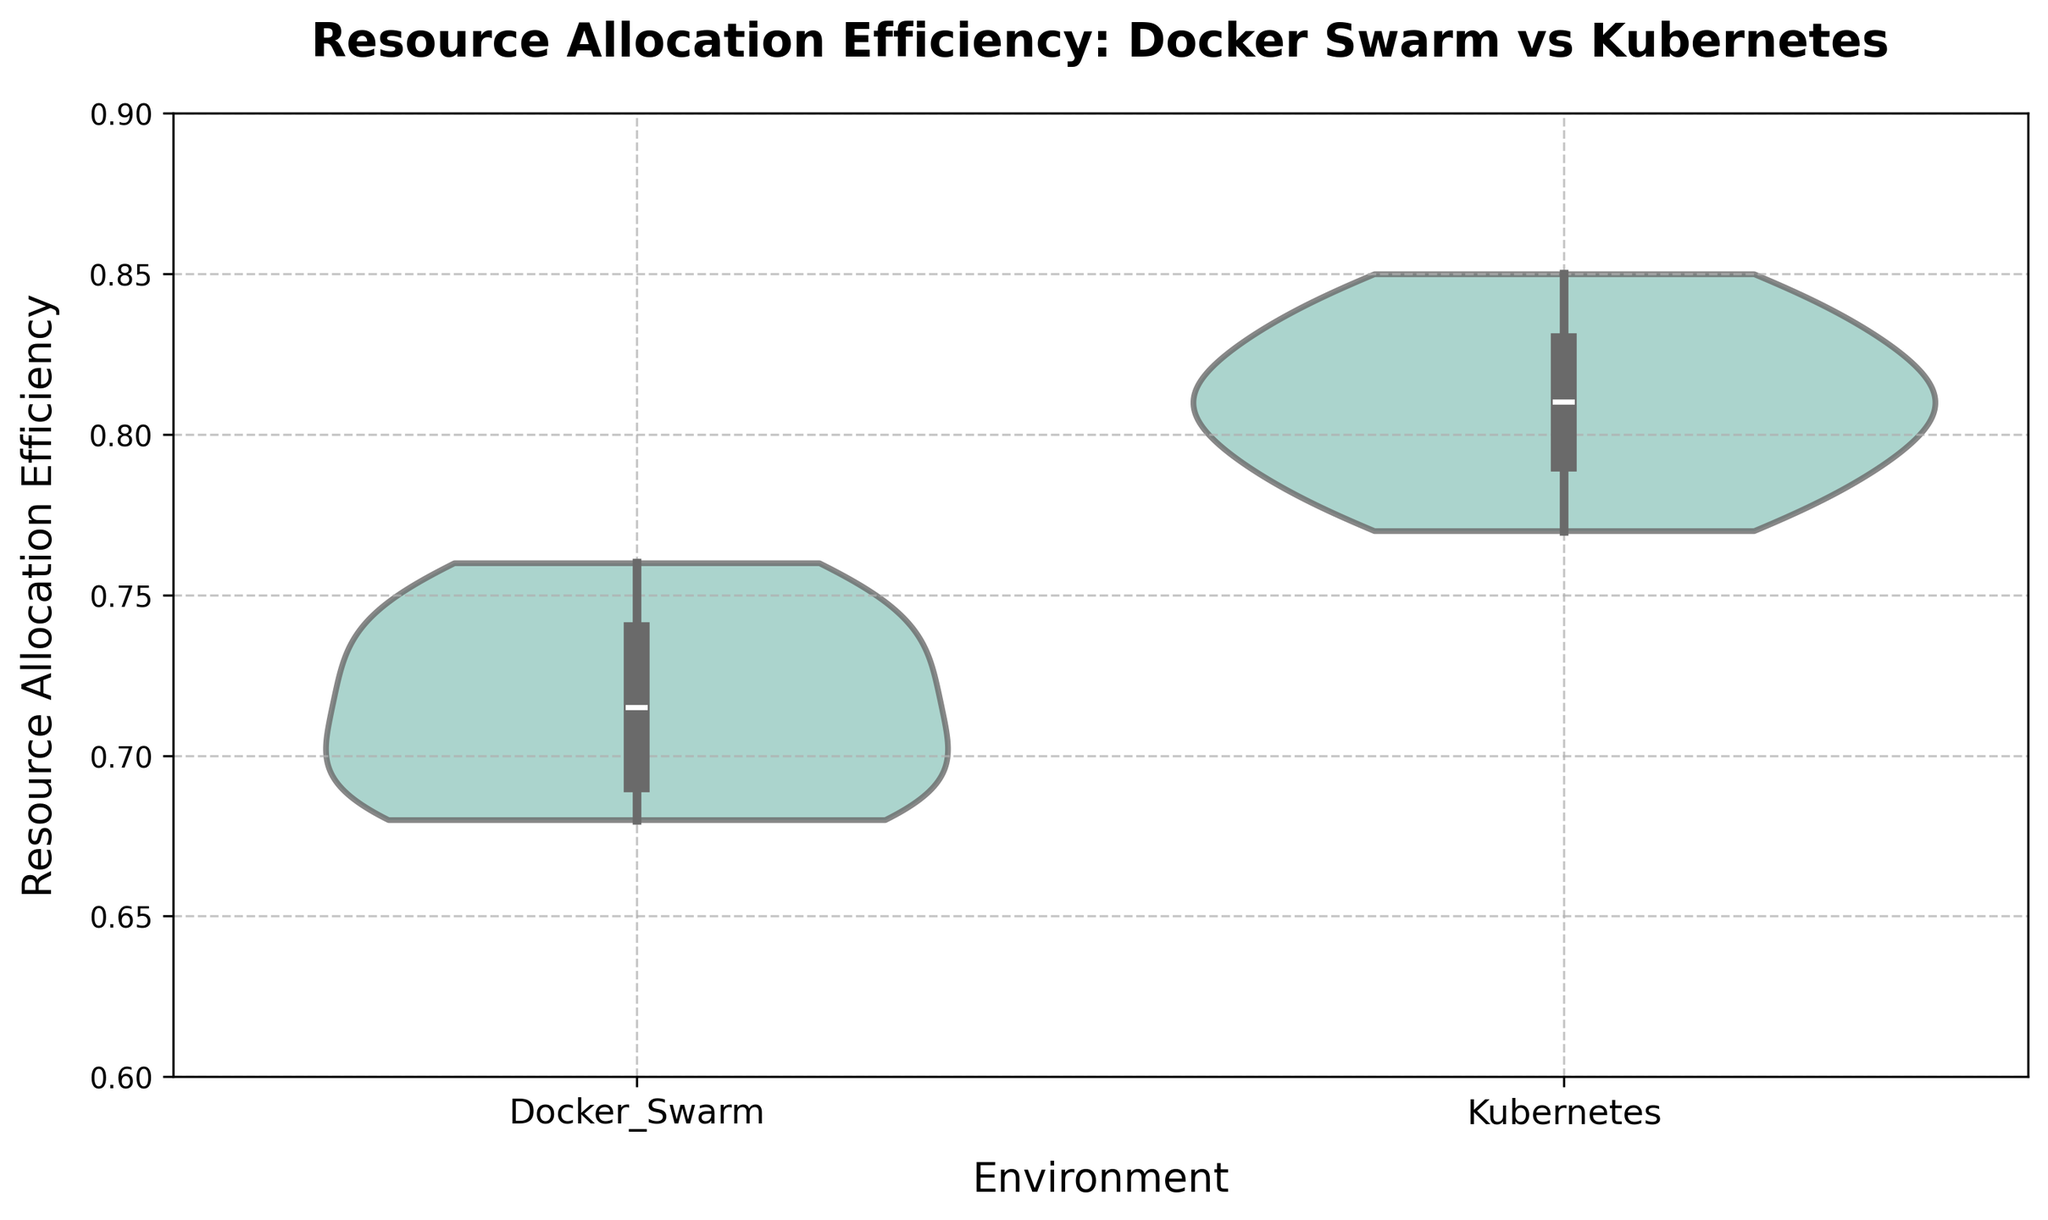what's the title of the figure? The title is generally placed at the top and it's meant to give an overview of what the figure represents. The title in this case would be directly visible.
Answer: Resource Allocation Efficiency: Docker Swarm vs Kubernetes what are the two environments compared in the figure? The environments are indicated on the x-axis and labeled as categories. These represent the two groups being compared in the dataset.
Answer: Docker Swarm and Kubernetes what is the range of resource allocation efficiency shown in the y-axis? The y-axis typically shows the range of values being measured, and the plot limits define this range. Based on the figure, we can see the defined limits for resource allocation efficiency.
Answer: 0.6 to 0.9 which environment shows the higher median resource allocation efficiency? The median line is visible inside each violin. By comparing these lines between the two environments, we can determine which one is higher.
Answer: Kubernetes which environment exhibits a wider spread in resource allocation efficiency? The shape of the violin represents the data distribution. A wider shape means a larger spread. By examining the width of each violin, we can determine which environment has a greater spread.
Answer: Docker Swarm are there any visible outliers in either environment? Outliers in a violin plot are typically shown as dots outside the main distribution. By looking at the figure, you can determine the presence of any outliers.
Answer: No how does the interquartile range (IQR) of Docker Swarm compare to that of Kubernetes? The IQR is the area between the 25th and 75th percentiles, typically highlighted within a box in the violin plot. By examining the boxes within each violin, we can compare the IQRs.
Answer: Docker Swarm has a narrower IQR compared to Kubernetes which environment has the least efficient resource allocation value recorded? By observing the lowest point of the distribution in each violin, we can identify the minimum recorded value.
Answer: Docker Swarm what can you infer about the consistency of resource allocation efficiency in Docker Swarm vs Kubernetes? By looking at the shape and spread of the violins and boxes within them, we can infer the consistency. A tighter distribution indicates more consistency.
Answer: Kubernetes is more consistent based on the plot, is there a significant overlap in the resource allocation efficiency distributions between Docker Swarm and Kubernetes? Overlap in the distributions is visible in the plot where the shapes of the violins for both environments intersect. By examining this overlap, we can infer if there is significant overlap or not.
Answer: No significant overlap 